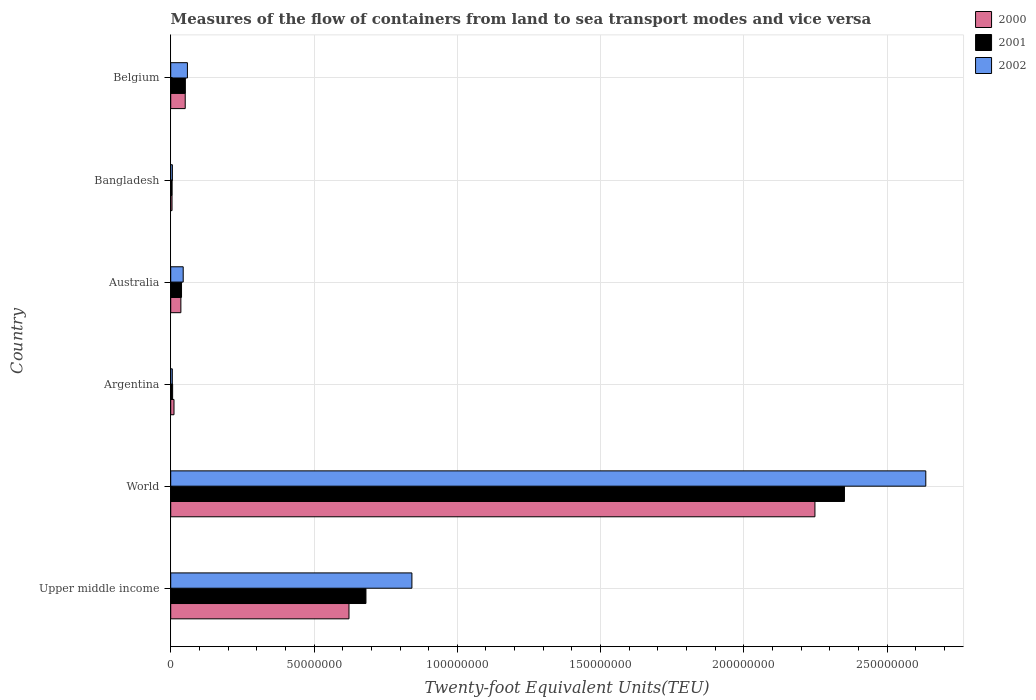How many different coloured bars are there?
Offer a terse response. 3. Are the number of bars on each tick of the Y-axis equal?
Keep it short and to the point. Yes. How many bars are there on the 2nd tick from the top?
Your response must be concise. 3. What is the container port traffic in 2002 in Argentina?
Offer a very short reply. 5.55e+05. Across all countries, what is the maximum container port traffic in 2001?
Your answer should be compact. 2.35e+08. Across all countries, what is the minimum container port traffic in 2001?
Offer a terse response. 4.86e+05. What is the total container port traffic in 2000 in the graph?
Offer a very short reply. 2.97e+08. What is the difference between the container port traffic in 2000 in Australia and that in Belgium?
Your answer should be very brief. -1.51e+06. What is the difference between the container port traffic in 2001 in World and the container port traffic in 2000 in Australia?
Your answer should be compact. 2.32e+08. What is the average container port traffic in 2000 per country?
Provide a succinct answer. 4.95e+07. What is the difference between the container port traffic in 2000 and container port traffic in 2001 in World?
Keep it short and to the point. -1.03e+07. In how many countries, is the container port traffic in 2000 greater than 170000000 TEU?
Offer a terse response. 1. What is the ratio of the container port traffic in 2001 in Argentina to that in Australia?
Ensure brevity in your answer.  0.18. What is the difference between the highest and the second highest container port traffic in 2001?
Keep it short and to the point. 1.67e+08. What is the difference between the highest and the lowest container port traffic in 2002?
Keep it short and to the point. 2.63e+08. Is the sum of the container port traffic in 2002 in Bangladesh and Belgium greater than the maximum container port traffic in 2001 across all countries?
Your answer should be very brief. No. How many countries are there in the graph?
Offer a terse response. 6. What is the difference between two consecutive major ticks on the X-axis?
Offer a very short reply. 5.00e+07. Are the values on the major ticks of X-axis written in scientific E-notation?
Give a very brief answer. No. Does the graph contain any zero values?
Offer a very short reply. No. How many legend labels are there?
Ensure brevity in your answer.  3. What is the title of the graph?
Provide a short and direct response. Measures of the flow of containers from land to sea transport modes and vice versa. What is the label or title of the X-axis?
Offer a very short reply. Twenty-foot Equivalent Units(TEU). What is the label or title of the Y-axis?
Provide a short and direct response. Country. What is the Twenty-foot Equivalent Units(TEU) in 2000 in Upper middle income?
Offer a terse response. 6.22e+07. What is the Twenty-foot Equivalent Units(TEU) of 2001 in Upper middle income?
Make the answer very short. 6.81e+07. What is the Twenty-foot Equivalent Units(TEU) in 2002 in Upper middle income?
Give a very brief answer. 8.42e+07. What is the Twenty-foot Equivalent Units(TEU) of 2000 in World?
Offer a terse response. 2.25e+08. What is the Twenty-foot Equivalent Units(TEU) of 2001 in World?
Provide a short and direct response. 2.35e+08. What is the Twenty-foot Equivalent Units(TEU) of 2002 in World?
Offer a terse response. 2.63e+08. What is the Twenty-foot Equivalent Units(TEU) of 2000 in Argentina?
Keep it short and to the point. 1.14e+06. What is the Twenty-foot Equivalent Units(TEU) of 2001 in Argentina?
Your answer should be very brief. 6.64e+05. What is the Twenty-foot Equivalent Units(TEU) in 2002 in Argentina?
Provide a short and direct response. 5.55e+05. What is the Twenty-foot Equivalent Units(TEU) of 2000 in Australia?
Your response must be concise. 3.54e+06. What is the Twenty-foot Equivalent Units(TEU) of 2001 in Australia?
Offer a very short reply. 3.77e+06. What is the Twenty-foot Equivalent Units(TEU) in 2002 in Australia?
Your answer should be very brief. 4.36e+06. What is the Twenty-foot Equivalent Units(TEU) of 2000 in Bangladesh?
Offer a very short reply. 4.56e+05. What is the Twenty-foot Equivalent Units(TEU) of 2001 in Bangladesh?
Make the answer very short. 4.86e+05. What is the Twenty-foot Equivalent Units(TEU) of 2002 in Bangladesh?
Your answer should be very brief. 5.84e+05. What is the Twenty-foot Equivalent Units(TEU) of 2000 in Belgium?
Offer a very short reply. 5.06e+06. What is the Twenty-foot Equivalent Units(TEU) of 2001 in Belgium?
Provide a succinct answer. 5.11e+06. What is the Twenty-foot Equivalent Units(TEU) in 2002 in Belgium?
Offer a terse response. 5.83e+06. Across all countries, what is the maximum Twenty-foot Equivalent Units(TEU) of 2000?
Ensure brevity in your answer.  2.25e+08. Across all countries, what is the maximum Twenty-foot Equivalent Units(TEU) in 2001?
Offer a very short reply. 2.35e+08. Across all countries, what is the maximum Twenty-foot Equivalent Units(TEU) of 2002?
Provide a short and direct response. 2.63e+08. Across all countries, what is the minimum Twenty-foot Equivalent Units(TEU) of 2000?
Make the answer very short. 4.56e+05. Across all countries, what is the minimum Twenty-foot Equivalent Units(TEU) of 2001?
Keep it short and to the point. 4.86e+05. Across all countries, what is the minimum Twenty-foot Equivalent Units(TEU) in 2002?
Your response must be concise. 5.55e+05. What is the total Twenty-foot Equivalent Units(TEU) in 2000 in the graph?
Ensure brevity in your answer.  2.97e+08. What is the total Twenty-foot Equivalent Units(TEU) in 2001 in the graph?
Give a very brief answer. 3.13e+08. What is the total Twenty-foot Equivalent Units(TEU) of 2002 in the graph?
Keep it short and to the point. 3.59e+08. What is the difference between the Twenty-foot Equivalent Units(TEU) of 2000 in Upper middle income and that in World?
Keep it short and to the point. -1.63e+08. What is the difference between the Twenty-foot Equivalent Units(TEU) in 2001 in Upper middle income and that in World?
Offer a terse response. -1.67e+08. What is the difference between the Twenty-foot Equivalent Units(TEU) of 2002 in Upper middle income and that in World?
Provide a succinct answer. -1.79e+08. What is the difference between the Twenty-foot Equivalent Units(TEU) in 2000 in Upper middle income and that in Argentina?
Provide a succinct answer. 6.11e+07. What is the difference between the Twenty-foot Equivalent Units(TEU) in 2001 in Upper middle income and that in Argentina?
Offer a terse response. 6.75e+07. What is the difference between the Twenty-foot Equivalent Units(TEU) in 2002 in Upper middle income and that in Argentina?
Give a very brief answer. 8.36e+07. What is the difference between the Twenty-foot Equivalent Units(TEU) of 2000 in Upper middle income and that in Australia?
Your answer should be very brief. 5.87e+07. What is the difference between the Twenty-foot Equivalent Units(TEU) in 2001 in Upper middle income and that in Australia?
Ensure brevity in your answer.  6.43e+07. What is the difference between the Twenty-foot Equivalent Units(TEU) of 2002 in Upper middle income and that in Australia?
Give a very brief answer. 7.98e+07. What is the difference between the Twenty-foot Equivalent Units(TEU) in 2000 in Upper middle income and that in Bangladesh?
Provide a short and direct response. 6.17e+07. What is the difference between the Twenty-foot Equivalent Units(TEU) in 2001 in Upper middle income and that in Bangladesh?
Make the answer very short. 6.76e+07. What is the difference between the Twenty-foot Equivalent Units(TEU) in 2002 in Upper middle income and that in Bangladesh?
Your answer should be compact. 8.36e+07. What is the difference between the Twenty-foot Equivalent Units(TEU) of 2000 in Upper middle income and that in Belgium?
Keep it short and to the point. 5.71e+07. What is the difference between the Twenty-foot Equivalent Units(TEU) of 2001 in Upper middle income and that in Belgium?
Offer a very short reply. 6.30e+07. What is the difference between the Twenty-foot Equivalent Units(TEU) in 2002 in Upper middle income and that in Belgium?
Make the answer very short. 7.83e+07. What is the difference between the Twenty-foot Equivalent Units(TEU) of 2000 in World and that in Argentina?
Offer a terse response. 2.24e+08. What is the difference between the Twenty-foot Equivalent Units(TEU) in 2001 in World and that in Argentina?
Ensure brevity in your answer.  2.34e+08. What is the difference between the Twenty-foot Equivalent Units(TEU) of 2002 in World and that in Argentina?
Give a very brief answer. 2.63e+08. What is the difference between the Twenty-foot Equivalent Units(TEU) in 2000 in World and that in Australia?
Provide a short and direct response. 2.21e+08. What is the difference between the Twenty-foot Equivalent Units(TEU) of 2001 in World and that in Australia?
Offer a terse response. 2.31e+08. What is the difference between the Twenty-foot Equivalent Units(TEU) of 2002 in World and that in Australia?
Provide a succinct answer. 2.59e+08. What is the difference between the Twenty-foot Equivalent Units(TEU) in 2000 in World and that in Bangladesh?
Give a very brief answer. 2.24e+08. What is the difference between the Twenty-foot Equivalent Units(TEU) in 2001 in World and that in Bangladesh?
Your response must be concise. 2.35e+08. What is the difference between the Twenty-foot Equivalent Units(TEU) of 2002 in World and that in Bangladesh?
Provide a succinct answer. 2.63e+08. What is the difference between the Twenty-foot Equivalent Units(TEU) of 2000 in World and that in Belgium?
Provide a succinct answer. 2.20e+08. What is the difference between the Twenty-foot Equivalent Units(TEU) in 2001 in World and that in Belgium?
Give a very brief answer. 2.30e+08. What is the difference between the Twenty-foot Equivalent Units(TEU) in 2002 in World and that in Belgium?
Offer a terse response. 2.58e+08. What is the difference between the Twenty-foot Equivalent Units(TEU) of 2000 in Argentina and that in Australia?
Your answer should be very brief. -2.40e+06. What is the difference between the Twenty-foot Equivalent Units(TEU) in 2001 in Argentina and that in Australia?
Your answer should be very brief. -3.11e+06. What is the difference between the Twenty-foot Equivalent Units(TEU) of 2002 in Argentina and that in Australia?
Your answer should be compact. -3.80e+06. What is the difference between the Twenty-foot Equivalent Units(TEU) in 2000 in Argentina and that in Bangladesh?
Your response must be concise. 6.89e+05. What is the difference between the Twenty-foot Equivalent Units(TEU) in 2001 in Argentina and that in Bangladesh?
Provide a short and direct response. 1.78e+05. What is the difference between the Twenty-foot Equivalent Units(TEU) of 2002 in Argentina and that in Bangladesh?
Your response must be concise. -2.94e+04. What is the difference between the Twenty-foot Equivalent Units(TEU) in 2000 in Argentina and that in Belgium?
Your answer should be compact. -3.91e+06. What is the difference between the Twenty-foot Equivalent Units(TEU) in 2001 in Argentina and that in Belgium?
Provide a short and direct response. -4.45e+06. What is the difference between the Twenty-foot Equivalent Units(TEU) in 2002 in Argentina and that in Belgium?
Your answer should be compact. -5.27e+06. What is the difference between the Twenty-foot Equivalent Units(TEU) of 2000 in Australia and that in Bangladesh?
Offer a terse response. 3.09e+06. What is the difference between the Twenty-foot Equivalent Units(TEU) of 2001 in Australia and that in Bangladesh?
Offer a terse response. 3.29e+06. What is the difference between the Twenty-foot Equivalent Units(TEU) of 2002 in Australia and that in Bangladesh?
Provide a short and direct response. 3.77e+06. What is the difference between the Twenty-foot Equivalent Units(TEU) of 2000 in Australia and that in Belgium?
Provide a short and direct response. -1.51e+06. What is the difference between the Twenty-foot Equivalent Units(TEU) in 2001 in Australia and that in Belgium?
Offer a very short reply. -1.33e+06. What is the difference between the Twenty-foot Equivalent Units(TEU) of 2002 in Australia and that in Belgium?
Your answer should be very brief. -1.47e+06. What is the difference between the Twenty-foot Equivalent Units(TEU) in 2000 in Bangladesh and that in Belgium?
Your answer should be compact. -4.60e+06. What is the difference between the Twenty-foot Equivalent Units(TEU) in 2001 in Bangladesh and that in Belgium?
Offer a terse response. -4.62e+06. What is the difference between the Twenty-foot Equivalent Units(TEU) in 2002 in Bangladesh and that in Belgium?
Your answer should be compact. -5.24e+06. What is the difference between the Twenty-foot Equivalent Units(TEU) in 2000 in Upper middle income and the Twenty-foot Equivalent Units(TEU) in 2001 in World?
Your answer should be compact. -1.73e+08. What is the difference between the Twenty-foot Equivalent Units(TEU) in 2000 in Upper middle income and the Twenty-foot Equivalent Units(TEU) in 2002 in World?
Keep it short and to the point. -2.01e+08. What is the difference between the Twenty-foot Equivalent Units(TEU) of 2001 in Upper middle income and the Twenty-foot Equivalent Units(TEU) of 2002 in World?
Ensure brevity in your answer.  -1.95e+08. What is the difference between the Twenty-foot Equivalent Units(TEU) of 2000 in Upper middle income and the Twenty-foot Equivalent Units(TEU) of 2001 in Argentina?
Keep it short and to the point. 6.15e+07. What is the difference between the Twenty-foot Equivalent Units(TEU) in 2000 in Upper middle income and the Twenty-foot Equivalent Units(TEU) in 2002 in Argentina?
Give a very brief answer. 6.16e+07. What is the difference between the Twenty-foot Equivalent Units(TEU) of 2001 in Upper middle income and the Twenty-foot Equivalent Units(TEU) of 2002 in Argentina?
Provide a short and direct response. 6.76e+07. What is the difference between the Twenty-foot Equivalent Units(TEU) in 2000 in Upper middle income and the Twenty-foot Equivalent Units(TEU) in 2001 in Australia?
Ensure brevity in your answer.  5.84e+07. What is the difference between the Twenty-foot Equivalent Units(TEU) of 2000 in Upper middle income and the Twenty-foot Equivalent Units(TEU) of 2002 in Australia?
Your response must be concise. 5.78e+07. What is the difference between the Twenty-foot Equivalent Units(TEU) of 2001 in Upper middle income and the Twenty-foot Equivalent Units(TEU) of 2002 in Australia?
Provide a short and direct response. 6.38e+07. What is the difference between the Twenty-foot Equivalent Units(TEU) of 2000 in Upper middle income and the Twenty-foot Equivalent Units(TEU) of 2001 in Bangladesh?
Provide a short and direct response. 6.17e+07. What is the difference between the Twenty-foot Equivalent Units(TEU) of 2000 in Upper middle income and the Twenty-foot Equivalent Units(TEU) of 2002 in Bangladesh?
Offer a very short reply. 6.16e+07. What is the difference between the Twenty-foot Equivalent Units(TEU) of 2001 in Upper middle income and the Twenty-foot Equivalent Units(TEU) of 2002 in Bangladesh?
Provide a short and direct response. 6.75e+07. What is the difference between the Twenty-foot Equivalent Units(TEU) of 2000 in Upper middle income and the Twenty-foot Equivalent Units(TEU) of 2001 in Belgium?
Your answer should be compact. 5.71e+07. What is the difference between the Twenty-foot Equivalent Units(TEU) in 2000 in Upper middle income and the Twenty-foot Equivalent Units(TEU) in 2002 in Belgium?
Give a very brief answer. 5.64e+07. What is the difference between the Twenty-foot Equivalent Units(TEU) of 2001 in Upper middle income and the Twenty-foot Equivalent Units(TEU) of 2002 in Belgium?
Offer a terse response. 6.23e+07. What is the difference between the Twenty-foot Equivalent Units(TEU) of 2000 in World and the Twenty-foot Equivalent Units(TEU) of 2001 in Argentina?
Your response must be concise. 2.24e+08. What is the difference between the Twenty-foot Equivalent Units(TEU) in 2000 in World and the Twenty-foot Equivalent Units(TEU) in 2002 in Argentina?
Give a very brief answer. 2.24e+08. What is the difference between the Twenty-foot Equivalent Units(TEU) in 2001 in World and the Twenty-foot Equivalent Units(TEU) in 2002 in Argentina?
Give a very brief answer. 2.35e+08. What is the difference between the Twenty-foot Equivalent Units(TEU) of 2000 in World and the Twenty-foot Equivalent Units(TEU) of 2001 in Australia?
Ensure brevity in your answer.  2.21e+08. What is the difference between the Twenty-foot Equivalent Units(TEU) of 2000 in World and the Twenty-foot Equivalent Units(TEU) of 2002 in Australia?
Offer a very short reply. 2.20e+08. What is the difference between the Twenty-foot Equivalent Units(TEU) in 2001 in World and the Twenty-foot Equivalent Units(TEU) in 2002 in Australia?
Offer a terse response. 2.31e+08. What is the difference between the Twenty-foot Equivalent Units(TEU) in 2000 in World and the Twenty-foot Equivalent Units(TEU) in 2001 in Bangladesh?
Your answer should be very brief. 2.24e+08. What is the difference between the Twenty-foot Equivalent Units(TEU) in 2000 in World and the Twenty-foot Equivalent Units(TEU) in 2002 in Bangladesh?
Your answer should be compact. 2.24e+08. What is the difference between the Twenty-foot Equivalent Units(TEU) in 2001 in World and the Twenty-foot Equivalent Units(TEU) in 2002 in Bangladesh?
Provide a succinct answer. 2.34e+08. What is the difference between the Twenty-foot Equivalent Units(TEU) of 2000 in World and the Twenty-foot Equivalent Units(TEU) of 2001 in Belgium?
Keep it short and to the point. 2.20e+08. What is the difference between the Twenty-foot Equivalent Units(TEU) in 2000 in World and the Twenty-foot Equivalent Units(TEU) in 2002 in Belgium?
Keep it short and to the point. 2.19e+08. What is the difference between the Twenty-foot Equivalent Units(TEU) in 2001 in World and the Twenty-foot Equivalent Units(TEU) in 2002 in Belgium?
Ensure brevity in your answer.  2.29e+08. What is the difference between the Twenty-foot Equivalent Units(TEU) of 2000 in Argentina and the Twenty-foot Equivalent Units(TEU) of 2001 in Australia?
Your answer should be compact. -2.63e+06. What is the difference between the Twenty-foot Equivalent Units(TEU) of 2000 in Argentina and the Twenty-foot Equivalent Units(TEU) of 2002 in Australia?
Your answer should be very brief. -3.21e+06. What is the difference between the Twenty-foot Equivalent Units(TEU) of 2001 in Argentina and the Twenty-foot Equivalent Units(TEU) of 2002 in Australia?
Offer a very short reply. -3.69e+06. What is the difference between the Twenty-foot Equivalent Units(TEU) of 2000 in Argentina and the Twenty-foot Equivalent Units(TEU) of 2001 in Bangladesh?
Give a very brief answer. 6.59e+05. What is the difference between the Twenty-foot Equivalent Units(TEU) in 2000 in Argentina and the Twenty-foot Equivalent Units(TEU) in 2002 in Bangladesh?
Make the answer very short. 5.61e+05. What is the difference between the Twenty-foot Equivalent Units(TEU) in 2001 in Argentina and the Twenty-foot Equivalent Units(TEU) in 2002 in Bangladesh?
Ensure brevity in your answer.  7.96e+04. What is the difference between the Twenty-foot Equivalent Units(TEU) in 2000 in Argentina and the Twenty-foot Equivalent Units(TEU) in 2001 in Belgium?
Ensure brevity in your answer.  -3.96e+06. What is the difference between the Twenty-foot Equivalent Units(TEU) of 2000 in Argentina and the Twenty-foot Equivalent Units(TEU) of 2002 in Belgium?
Provide a succinct answer. -4.68e+06. What is the difference between the Twenty-foot Equivalent Units(TEU) in 2001 in Argentina and the Twenty-foot Equivalent Units(TEU) in 2002 in Belgium?
Offer a very short reply. -5.16e+06. What is the difference between the Twenty-foot Equivalent Units(TEU) in 2000 in Australia and the Twenty-foot Equivalent Units(TEU) in 2001 in Bangladesh?
Your answer should be compact. 3.06e+06. What is the difference between the Twenty-foot Equivalent Units(TEU) of 2000 in Australia and the Twenty-foot Equivalent Units(TEU) of 2002 in Bangladesh?
Give a very brief answer. 2.96e+06. What is the difference between the Twenty-foot Equivalent Units(TEU) of 2001 in Australia and the Twenty-foot Equivalent Units(TEU) of 2002 in Bangladesh?
Your answer should be very brief. 3.19e+06. What is the difference between the Twenty-foot Equivalent Units(TEU) of 2000 in Australia and the Twenty-foot Equivalent Units(TEU) of 2001 in Belgium?
Ensure brevity in your answer.  -1.57e+06. What is the difference between the Twenty-foot Equivalent Units(TEU) of 2000 in Australia and the Twenty-foot Equivalent Units(TEU) of 2002 in Belgium?
Your answer should be compact. -2.28e+06. What is the difference between the Twenty-foot Equivalent Units(TEU) in 2001 in Australia and the Twenty-foot Equivalent Units(TEU) in 2002 in Belgium?
Your response must be concise. -2.05e+06. What is the difference between the Twenty-foot Equivalent Units(TEU) of 2000 in Bangladesh and the Twenty-foot Equivalent Units(TEU) of 2001 in Belgium?
Give a very brief answer. -4.65e+06. What is the difference between the Twenty-foot Equivalent Units(TEU) in 2000 in Bangladesh and the Twenty-foot Equivalent Units(TEU) in 2002 in Belgium?
Your answer should be compact. -5.37e+06. What is the difference between the Twenty-foot Equivalent Units(TEU) in 2001 in Bangladesh and the Twenty-foot Equivalent Units(TEU) in 2002 in Belgium?
Ensure brevity in your answer.  -5.34e+06. What is the average Twenty-foot Equivalent Units(TEU) of 2000 per country?
Provide a short and direct response. 4.95e+07. What is the average Twenty-foot Equivalent Units(TEU) in 2001 per country?
Give a very brief answer. 5.22e+07. What is the average Twenty-foot Equivalent Units(TEU) of 2002 per country?
Make the answer very short. 5.98e+07. What is the difference between the Twenty-foot Equivalent Units(TEU) of 2000 and Twenty-foot Equivalent Units(TEU) of 2001 in Upper middle income?
Keep it short and to the point. -5.92e+06. What is the difference between the Twenty-foot Equivalent Units(TEU) of 2000 and Twenty-foot Equivalent Units(TEU) of 2002 in Upper middle income?
Give a very brief answer. -2.20e+07. What is the difference between the Twenty-foot Equivalent Units(TEU) of 2001 and Twenty-foot Equivalent Units(TEU) of 2002 in Upper middle income?
Keep it short and to the point. -1.60e+07. What is the difference between the Twenty-foot Equivalent Units(TEU) in 2000 and Twenty-foot Equivalent Units(TEU) in 2001 in World?
Your answer should be compact. -1.03e+07. What is the difference between the Twenty-foot Equivalent Units(TEU) of 2000 and Twenty-foot Equivalent Units(TEU) of 2002 in World?
Ensure brevity in your answer.  -3.87e+07. What is the difference between the Twenty-foot Equivalent Units(TEU) of 2001 and Twenty-foot Equivalent Units(TEU) of 2002 in World?
Your answer should be very brief. -2.84e+07. What is the difference between the Twenty-foot Equivalent Units(TEU) of 2000 and Twenty-foot Equivalent Units(TEU) of 2001 in Argentina?
Your response must be concise. 4.81e+05. What is the difference between the Twenty-foot Equivalent Units(TEU) in 2000 and Twenty-foot Equivalent Units(TEU) in 2002 in Argentina?
Your response must be concise. 5.90e+05. What is the difference between the Twenty-foot Equivalent Units(TEU) of 2001 and Twenty-foot Equivalent Units(TEU) of 2002 in Argentina?
Offer a very short reply. 1.09e+05. What is the difference between the Twenty-foot Equivalent Units(TEU) in 2000 and Twenty-foot Equivalent Units(TEU) in 2001 in Australia?
Offer a terse response. -2.32e+05. What is the difference between the Twenty-foot Equivalent Units(TEU) in 2000 and Twenty-foot Equivalent Units(TEU) in 2002 in Australia?
Provide a short and direct response. -8.12e+05. What is the difference between the Twenty-foot Equivalent Units(TEU) of 2001 and Twenty-foot Equivalent Units(TEU) of 2002 in Australia?
Your response must be concise. -5.80e+05. What is the difference between the Twenty-foot Equivalent Units(TEU) in 2000 and Twenty-foot Equivalent Units(TEU) in 2001 in Bangladesh?
Your response must be concise. -3.03e+04. What is the difference between the Twenty-foot Equivalent Units(TEU) in 2000 and Twenty-foot Equivalent Units(TEU) in 2002 in Bangladesh?
Provide a succinct answer. -1.28e+05. What is the difference between the Twenty-foot Equivalent Units(TEU) of 2001 and Twenty-foot Equivalent Units(TEU) of 2002 in Bangladesh?
Your answer should be very brief. -9.79e+04. What is the difference between the Twenty-foot Equivalent Units(TEU) in 2000 and Twenty-foot Equivalent Units(TEU) in 2001 in Belgium?
Offer a very short reply. -5.21e+04. What is the difference between the Twenty-foot Equivalent Units(TEU) of 2000 and Twenty-foot Equivalent Units(TEU) of 2002 in Belgium?
Your answer should be compact. -7.68e+05. What is the difference between the Twenty-foot Equivalent Units(TEU) of 2001 and Twenty-foot Equivalent Units(TEU) of 2002 in Belgium?
Your answer should be very brief. -7.16e+05. What is the ratio of the Twenty-foot Equivalent Units(TEU) of 2000 in Upper middle income to that in World?
Offer a very short reply. 0.28. What is the ratio of the Twenty-foot Equivalent Units(TEU) of 2001 in Upper middle income to that in World?
Offer a terse response. 0.29. What is the ratio of the Twenty-foot Equivalent Units(TEU) of 2002 in Upper middle income to that in World?
Keep it short and to the point. 0.32. What is the ratio of the Twenty-foot Equivalent Units(TEU) of 2000 in Upper middle income to that in Argentina?
Ensure brevity in your answer.  54.33. What is the ratio of the Twenty-foot Equivalent Units(TEU) in 2001 in Upper middle income to that in Argentina?
Give a very brief answer. 102.62. What is the ratio of the Twenty-foot Equivalent Units(TEU) of 2002 in Upper middle income to that in Argentina?
Keep it short and to the point. 151.68. What is the ratio of the Twenty-foot Equivalent Units(TEU) in 2000 in Upper middle income to that in Australia?
Your answer should be compact. 17.56. What is the ratio of the Twenty-foot Equivalent Units(TEU) of 2001 in Upper middle income to that in Australia?
Keep it short and to the point. 18.05. What is the ratio of the Twenty-foot Equivalent Units(TEU) in 2002 in Upper middle income to that in Australia?
Your response must be concise. 19.32. What is the ratio of the Twenty-foot Equivalent Units(TEU) in 2000 in Upper middle income to that in Bangladesh?
Keep it short and to the point. 136.4. What is the ratio of the Twenty-foot Equivalent Units(TEU) in 2001 in Upper middle income to that in Bangladesh?
Offer a very short reply. 140.08. What is the ratio of the Twenty-foot Equivalent Units(TEU) of 2002 in Upper middle income to that in Bangladesh?
Provide a short and direct response. 144.04. What is the ratio of the Twenty-foot Equivalent Units(TEU) in 2000 in Upper middle income to that in Belgium?
Your answer should be very brief. 12.3. What is the ratio of the Twenty-foot Equivalent Units(TEU) in 2001 in Upper middle income to that in Belgium?
Ensure brevity in your answer.  13.33. What is the ratio of the Twenty-foot Equivalent Units(TEU) in 2002 in Upper middle income to that in Belgium?
Provide a short and direct response. 14.45. What is the ratio of the Twenty-foot Equivalent Units(TEU) in 2000 in World to that in Argentina?
Offer a terse response. 196.34. What is the ratio of the Twenty-foot Equivalent Units(TEU) in 2001 in World to that in Argentina?
Ensure brevity in your answer.  354.13. What is the ratio of the Twenty-foot Equivalent Units(TEU) in 2002 in World to that in Argentina?
Ensure brevity in your answer.  474.87. What is the ratio of the Twenty-foot Equivalent Units(TEU) in 2000 in World to that in Australia?
Provide a short and direct response. 63.45. What is the ratio of the Twenty-foot Equivalent Units(TEU) in 2001 in World to that in Australia?
Your answer should be very brief. 62.27. What is the ratio of the Twenty-foot Equivalent Units(TEU) of 2002 in World to that in Australia?
Provide a short and direct response. 60.49. What is the ratio of the Twenty-foot Equivalent Units(TEU) in 2000 in World to that in Bangladesh?
Your answer should be very brief. 492.92. What is the ratio of the Twenty-foot Equivalent Units(TEU) of 2001 in World to that in Bangladesh?
Offer a very short reply. 483.41. What is the ratio of the Twenty-foot Equivalent Units(TEU) in 2002 in World to that in Bangladesh?
Your answer should be very brief. 450.95. What is the ratio of the Twenty-foot Equivalent Units(TEU) in 2000 in World to that in Belgium?
Offer a very short reply. 44.44. What is the ratio of the Twenty-foot Equivalent Units(TEU) of 2001 in World to that in Belgium?
Give a very brief answer. 46.01. What is the ratio of the Twenty-foot Equivalent Units(TEU) of 2002 in World to that in Belgium?
Give a very brief answer. 45.22. What is the ratio of the Twenty-foot Equivalent Units(TEU) of 2000 in Argentina to that in Australia?
Offer a very short reply. 0.32. What is the ratio of the Twenty-foot Equivalent Units(TEU) of 2001 in Argentina to that in Australia?
Your response must be concise. 0.18. What is the ratio of the Twenty-foot Equivalent Units(TEU) in 2002 in Argentina to that in Australia?
Provide a succinct answer. 0.13. What is the ratio of the Twenty-foot Equivalent Units(TEU) of 2000 in Argentina to that in Bangladesh?
Your response must be concise. 2.51. What is the ratio of the Twenty-foot Equivalent Units(TEU) of 2001 in Argentina to that in Bangladesh?
Provide a succinct answer. 1.37. What is the ratio of the Twenty-foot Equivalent Units(TEU) of 2002 in Argentina to that in Bangladesh?
Provide a short and direct response. 0.95. What is the ratio of the Twenty-foot Equivalent Units(TEU) in 2000 in Argentina to that in Belgium?
Make the answer very short. 0.23. What is the ratio of the Twenty-foot Equivalent Units(TEU) in 2001 in Argentina to that in Belgium?
Your answer should be compact. 0.13. What is the ratio of the Twenty-foot Equivalent Units(TEU) in 2002 in Argentina to that in Belgium?
Your answer should be compact. 0.1. What is the ratio of the Twenty-foot Equivalent Units(TEU) in 2000 in Australia to that in Bangladesh?
Your response must be concise. 7.77. What is the ratio of the Twenty-foot Equivalent Units(TEU) of 2001 in Australia to that in Bangladesh?
Your response must be concise. 7.76. What is the ratio of the Twenty-foot Equivalent Units(TEU) of 2002 in Australia to that in Bangladesh?
Make the answer very short. 7.45. What is the ratio of the Twenty-foot Equivalent Units(TEU) of 2000 in Australia to that in Belgium?
Give a very brief answer. 0.7. What is the ratio of the Twenty-foot Equivalent Units(TEU) of 2001 in Australia to that in Belgium?
Your answer should be very brief. 0.74. What is the ratio of the Twenty-foot Equivalent Units(TEU) of 2002 in Australia to that in Belgium?
Your response must be concise. 0.75. What is the ratio of the Twenty-foot Equivalent Units(TEU) of 2000 in Bangladesh to that in Belgium?
Give a very brief answer. 0.09. What is the ratio of the Twenty-foot Equivalent Units(TEU) of 2001 in Bangladesh to that in Belgium?
Your response must be concise. 0.1. What is the ratio of the Twenty-foot Equivalent Units(TEU) in 2002 in Bangladesh to that in Belgium?
Ensure brevity in your answer.  0.1. What is the difference between the highest and the second highest Twenty-foot Equivalent Units(TEU) of 2000?
Your response must be concise. 1.63e+08. What is the difference between the highest and the second highest Twenty-foot Equivalent Units(TEU) of 2001?
Provide a succinct answer. 1.67e+08. What is the difference between the highest and the second highest Twenty-foot Equivalent Units(TEU) of 2002?
Offer a very short reply. 1.79e+08. What is the difference between the highest and the lowest Twenty-foot Equivalent Units(TEU) of 2000?
Your answer should be compact. 2.24e+08. What is the difference between the highest and the lowest Twenty-foot Equivalent Units(TEU) of 2001?
Your answer should be compact. 2.35e+08. What is the difference between the highest and the lowest Twenty-foot Equivalent Units(TEU) in 2002?
Make the answer very short. 2.63e+08. 